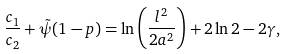Convert formula to latex. <formula><loc_0><loc_0><loc_500><loc_500>\frac { c _ { 1 } } { c _ { 2 } } + \tilde { \psi } ( 1 - p ) = \ln \left ( \frac { l ^ { 2 } } { 2 a ^ { 2 } } \right ) + 2 \ln { 2 } - 2 \gamma ,</formula> 